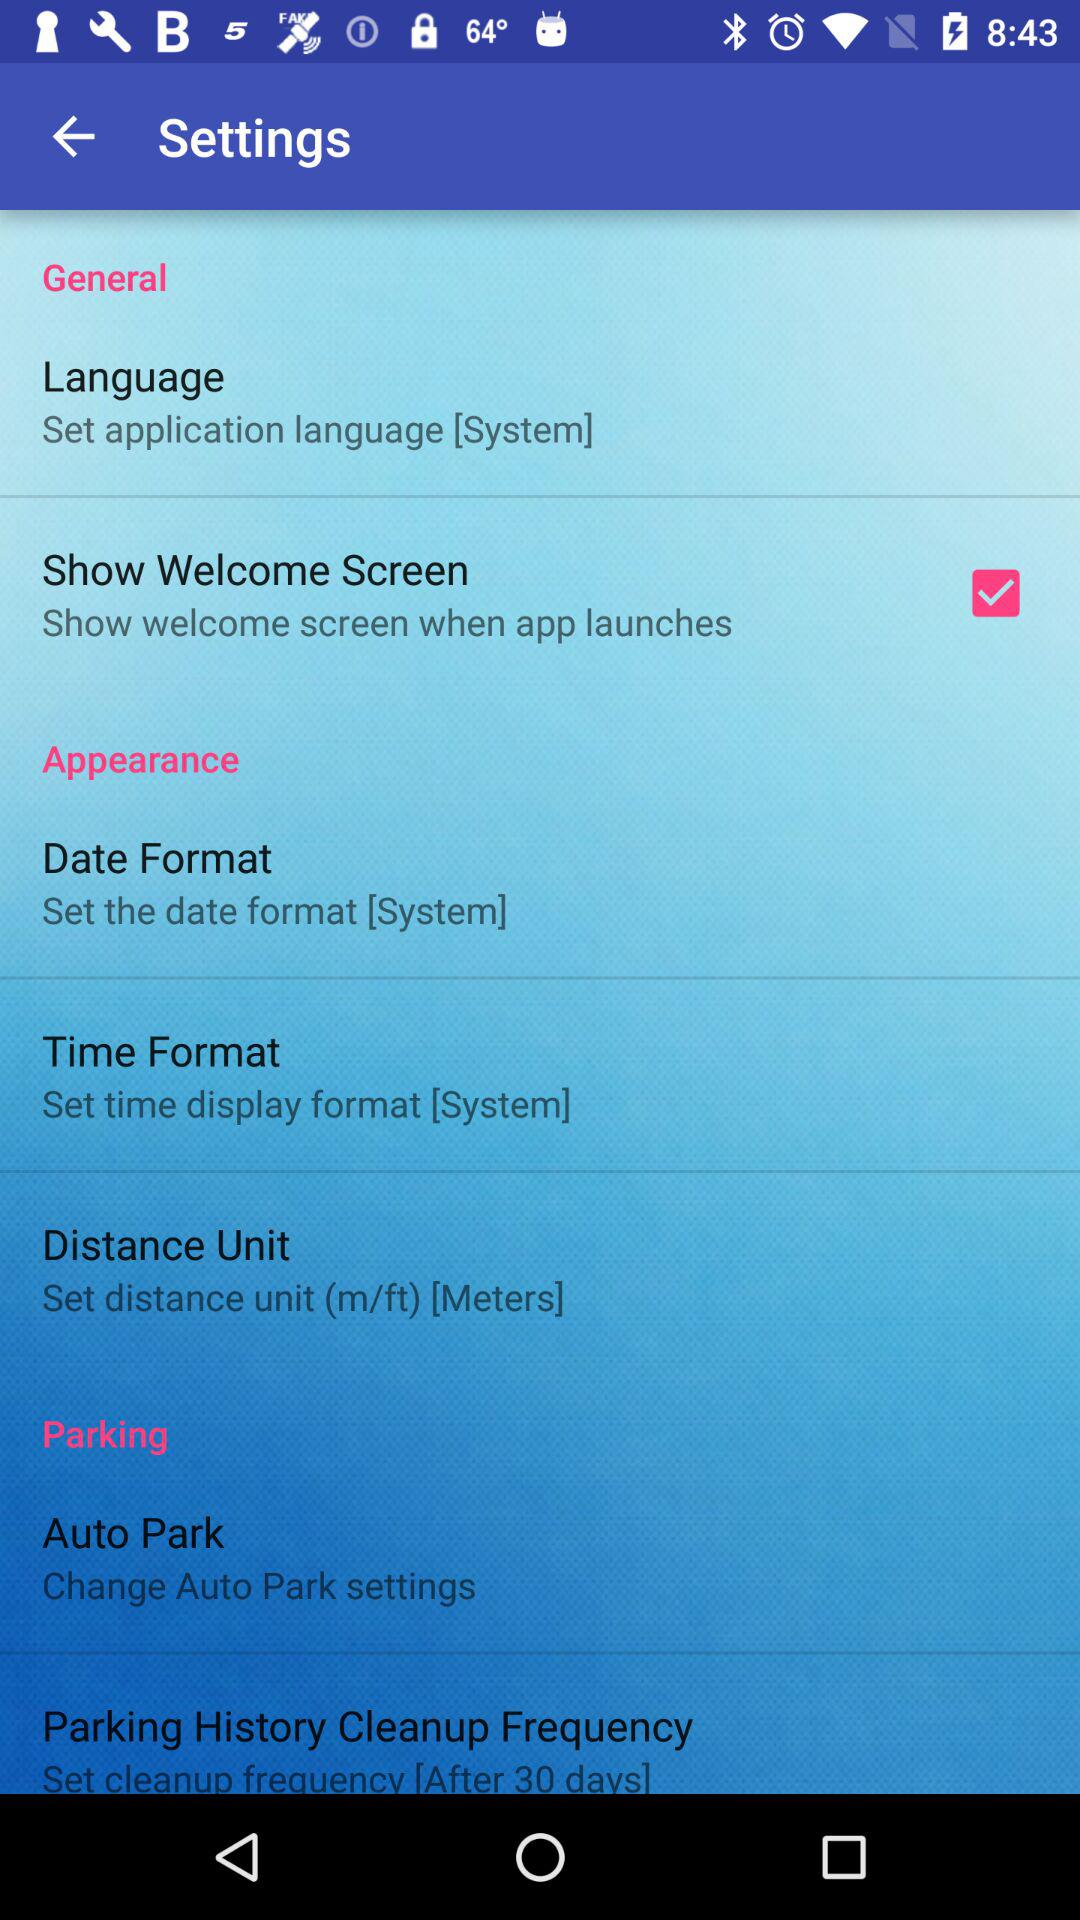What is the status of the "Show Welcome Screen"? The status is "on". 